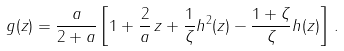Convert formula to latex. <formula><loc_0><loc_0><loc_500><loc_500>g ( z ) = \frac { a } { 2 + a } \left [ 1 + \frac { 2 } { a } \, z + \frac { 1 } { \zeta } h ^ { 2 } ( z ) - \frac { 1 + \zeta } { \zeta } h ( z ) \right ] \, .</formula> 